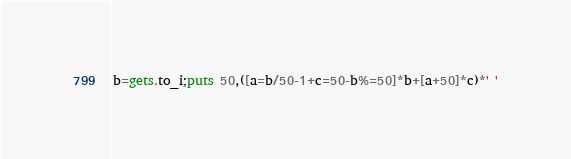Convert code to text. <code><loc_0><loc_0><loc_500><loc_500><_Ruby_>b=gets.to_i;puts 50,([a=b/50-1+c=50-b%=50]*b+[a+50]*c)*' '</code> 